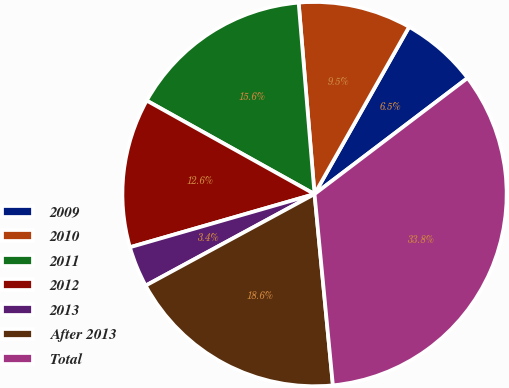Convert chart to OTSL. <chart><loc_0><loc_0><loc_500><loc_500><pie_chart><fcel>2009<fcel>2010<fcel>2011<fcel>2012<fcel>2013<fcel>After 2013<fcel>Total<nl><fcel>6.48%<fcel>9.51%<fcel>15.59%<fcel>12.55%<fcel>3.44%<fcel>18.62%<fcel>33.8%<nl></chart> 